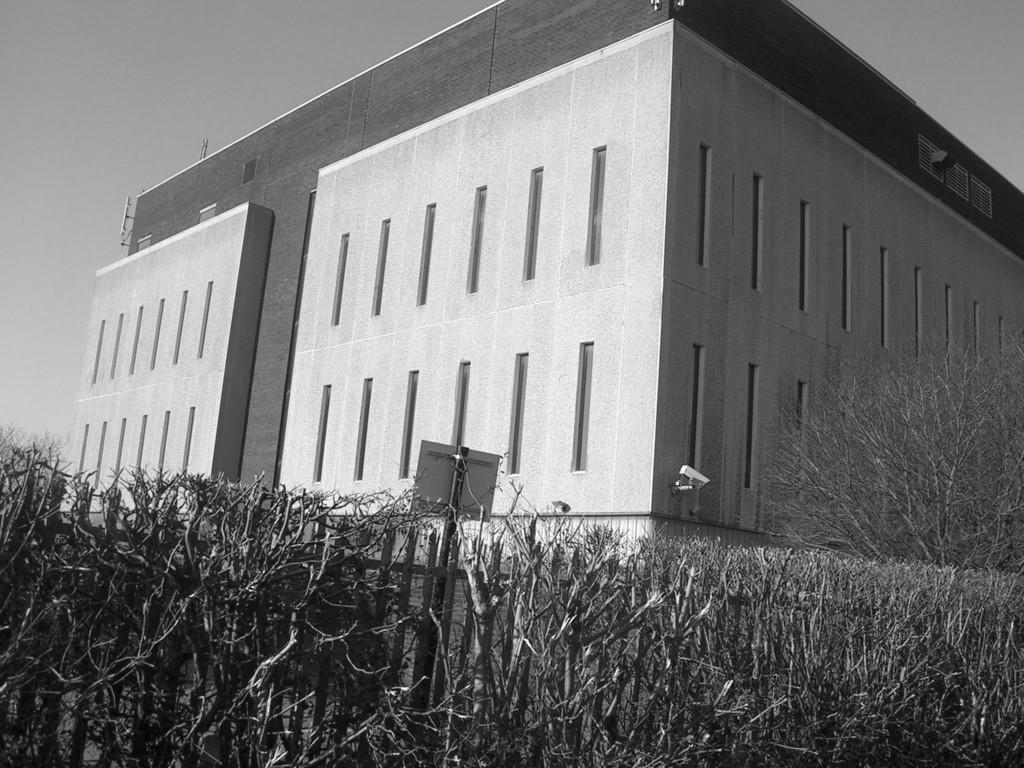In one or two sentences, can you explain what this image depicts? Here there is a building, these are plants. 